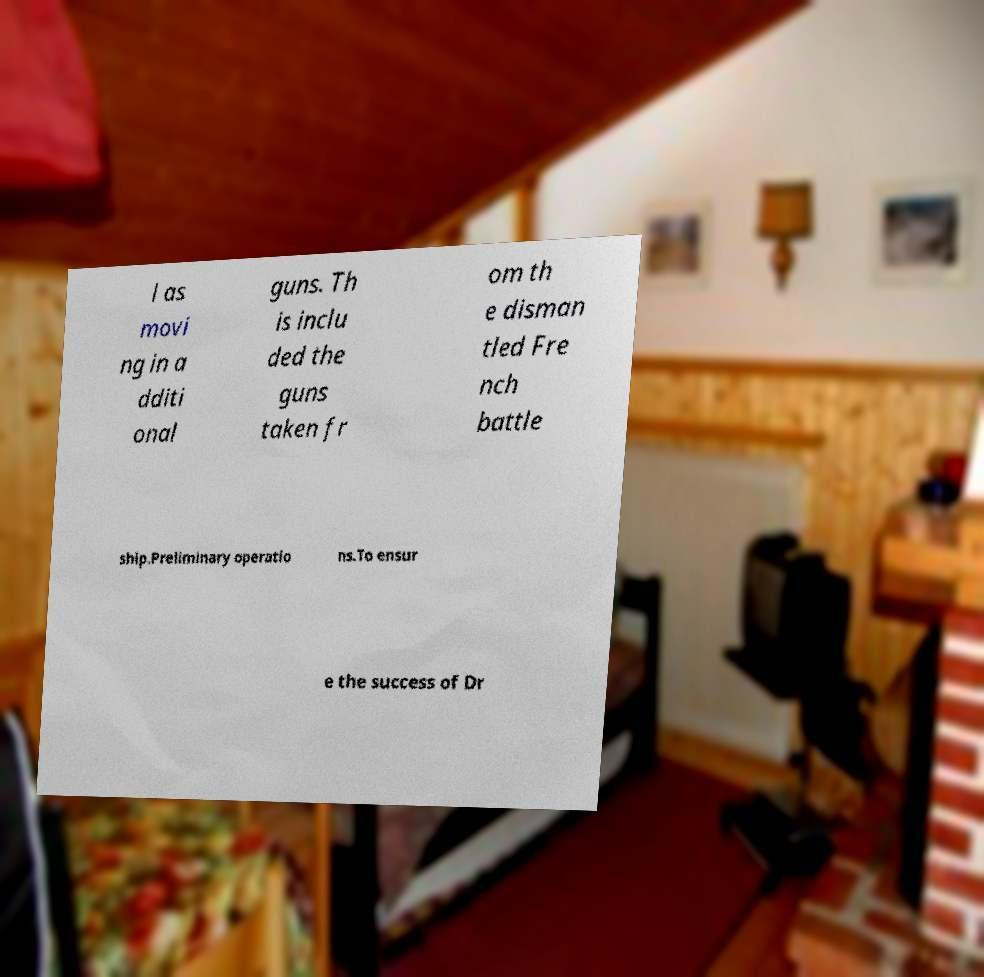Can you read and provide the text displayed in the image?This photo seems to have some interesting text. Can you extract and type it out for me? l as movi ng in a dditi onal guns. Th is inclu ded the guns taken fr om th e disman tled Fre nch battle ship.Preliminary operatio ns.To ensur e the success of Dr 